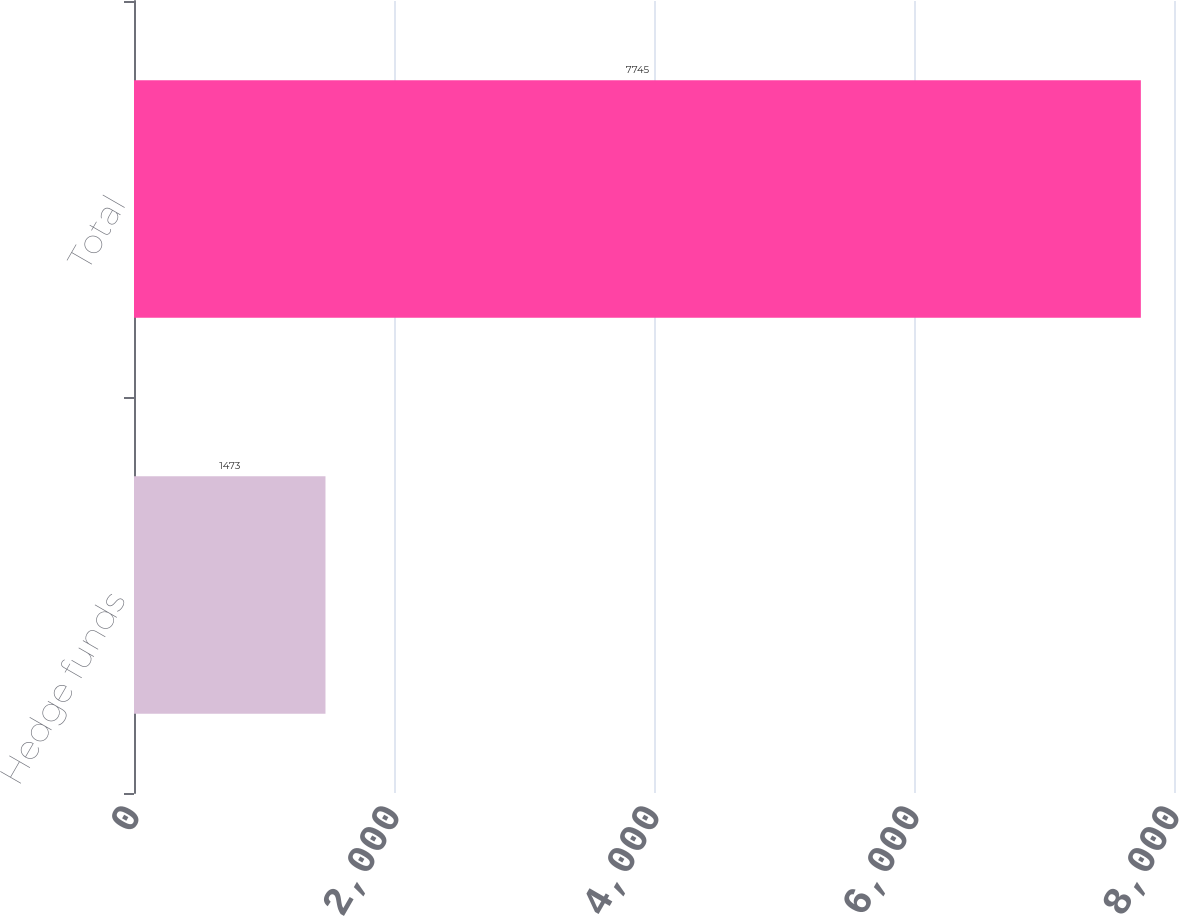Convert chart to OTSL. <chart><loc_0><loc_0><loc_500><loc_500><bar_chart><fcel>Hedge funds<fcel>Total<nl><fcel>1473<fcel>7745<nl></chart> 